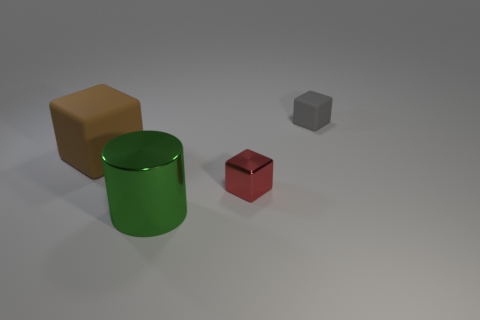Subtract all green blocks. Subtract all brown cylinders. How many blocks are left? 3 Add 4 blue blocks. How many objects exist? 8 Subtract all cubes. How many objects are left? 1 Add 2 tiny gray rubber balls. How many tiny gray rubber balls exist? 2 Subtract 1 brown blocks. How many objects are left? 3 Subtract all gray matte things. Subtract all small gray matte cubes. How many objects are left? 2 Add 4 tiny red blocks. How many tiny red blocks are left? 5 